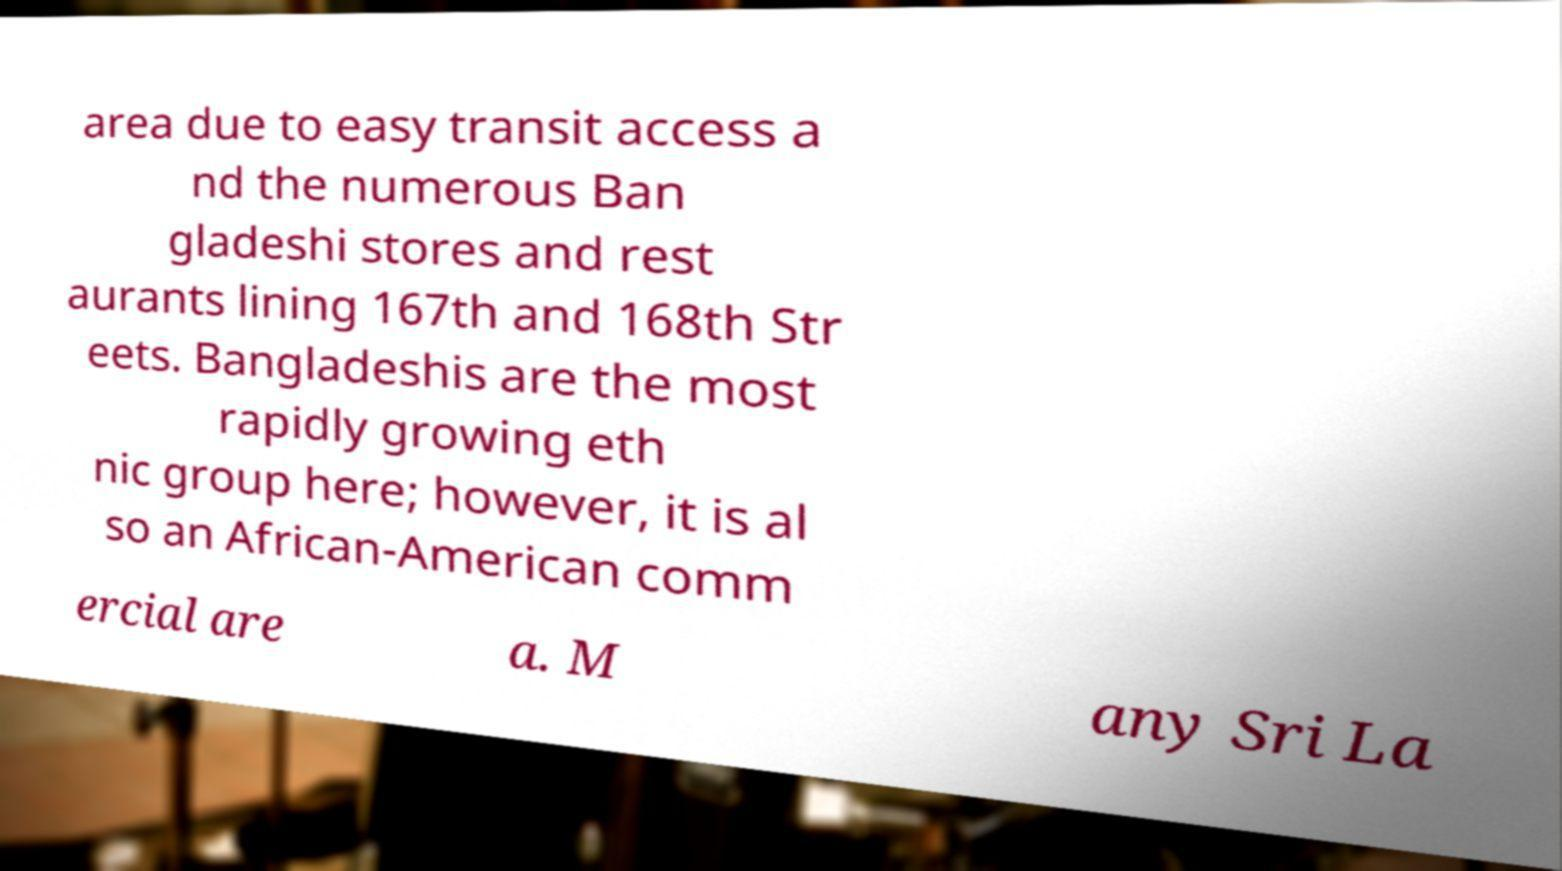I need the written content from this picture converted into text. Can you do that? area due to easy transit access a nd the numerous Ban gladeshi stores and rest aurants lining 167th and 168th Str eets. Bangladeshis are the most rapidly growing eth nic group here; however, it is al so an African-American comm ercial are a. M any Sri La 